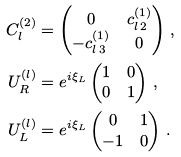<formula> <loc_0><loc_0><loc_500><loc_500>C ^ { ( 2 ) } _ { l } & = \begin{pmatrix} 0 & c ^ { ( 1 ) } _ { l \, 2 } \\ - c ^ { ( 1 ) } _ { l \, 3 } & 0 \end{pmatrix} \, , \\ U _ { R } ^ { ( l ) } & = e ^ { i \xi _ { L } } \begin{pmatrix} 1 & 0 \\ 0 & 1 \end{pmatrix} \, , \\ U _ { L } ^ { ( l ) } & = e ^ { i \xi _ { L } } \begin{pmatrix} 0 & 1 \\ - 1 & 0 \end{pmatrix} \, .</formula> 